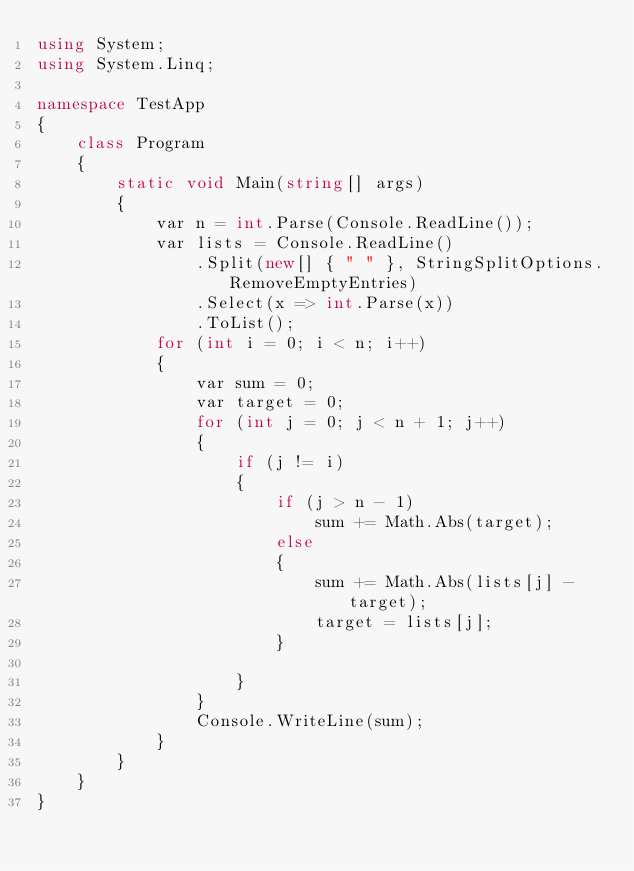Convert code to text. <code><loc_0><loc_0><loc_500><loc_500><_C#_>using System;
using System.Linq;

namespace TestApp
{
    class Program
    {
        static void Main(string[] args)
        {
            var n = int.Parse(Console.ReadLine());
            var lists = Console.ReadLine()
                .Split(new[] { " " }, StringSplitOptions.RemoveEmptyEntries)
                .Select(x => int.Parse(x))
                .ToList();
            for (int i = 0; i < n; i++)
            {
                var sum = 0;
                var target = 0;
                for (int j = 0; j < n + 1; j++)
                {
                    if (j != i)
                    {
                        if (j > n - 1)
                            sum += Math.Abs(target);
                        else
                        {
                            sum += Math.Abs(lists[j] - target);
                            target = lists[j];
                        }

                    }
                }
                Console.WriteLine(sum);
            }
        }
    }
}
</code> 